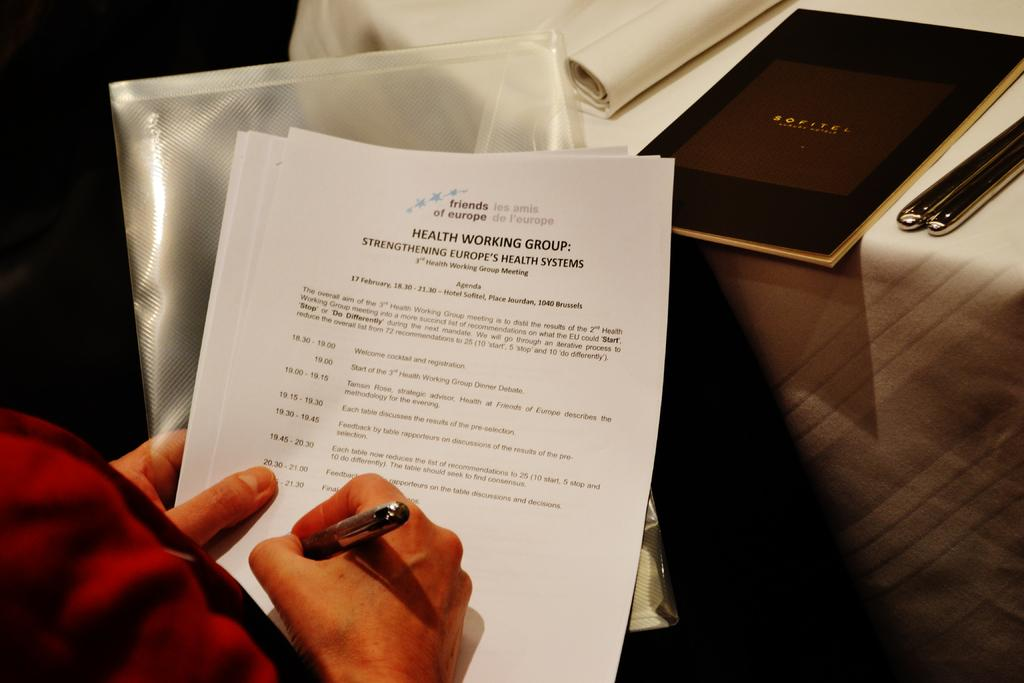<image>
Render a clear and concise summary of the photo. Someone is holding an agenda on Health at a dinner table. 